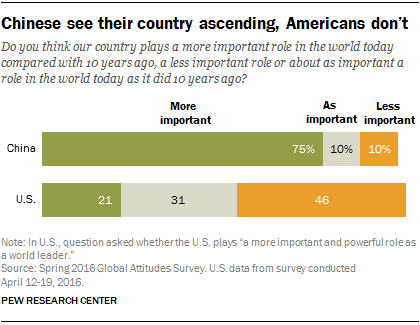Give some essential details in this illustration. A significant portion, approximately 75%, of opinions in China are considered more important. The ratio of the smallest orange bar and largest green bar is 0.46875... 